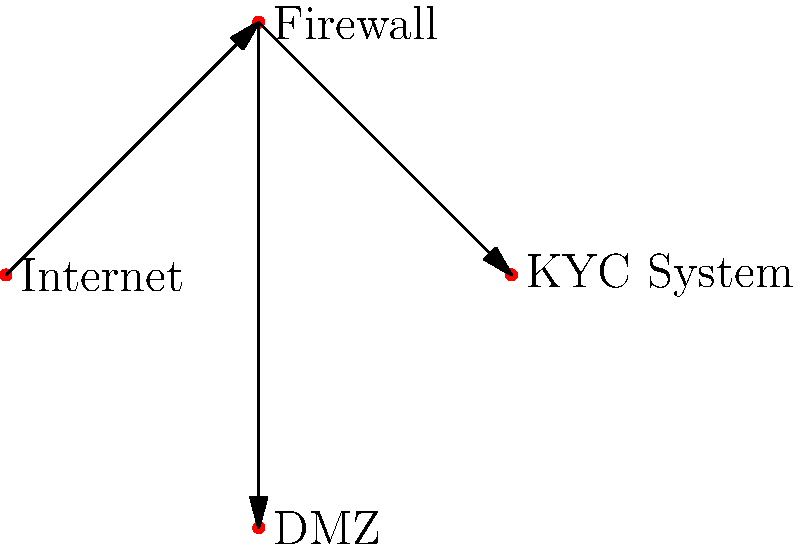In the network diagram shown, which firewall configuration would best protect sensitive customer data in the KYC system while allowing necessary access for agile development and updates? To determine the best firewall configuration for protecting sensitive customer data in a KYC system while allowing necessary access for agile development, we need to consider several factors:

1. Segmentation: The diagram shows a DMZ (Demilitarized Zone) separate from the KYC system, which is a good practice for isolating sensitive systems.

2. Access Control:
   a) Inbound traffic from the Internet should be strictly limited.
   b) Only necessary ports and protocols should be allowed to the KYC system.
   c) Access for development and updates should be controlled and monitored.

3. Rule Configuration:
   a) Default deny all inbound and outbound traffic.
   b) Allow only specific, necessary traffic to the KYC system.
   c) Implement stateful inspection for all allowed connections.

4. Application-layer filtering: Use application-layer firewalls to inspect and filter traffic based on the content and context of the data.

5. Logging and Monitoring: Enable comprehensive logging and real-time monitoring of all firewall activities.

6. VPN for remote access: Implement a secure VPN for developers to access the system remotely.

7. Regular updates: Keep the firewall software and rules up-to-date with the latest security patches and best practices.

The best configuration would be a next-generation firewall (NGFW) that combines traditional firewall capabilities with advanced features such as intrusion prevention, application awareness, and integrated threat intelligence. This would allow for:

- Strict control over inbound and outbound traffic
- Deep packet inspection for all traffic to and from the KYC system
- Application-level filtering to ensure only authorized applications can access sensitive data
- Integration with identity and access management systems for granular user control
- Secure VPN access for developers working on agile updates
- Comprehensive logging and monitoring capabilities for compliance and security audits

This configuration provides a balance between protecting sensitive customer data and allowing necessary access for agile development and updates.
Answer: Next-generation firewall (NGFW) with application-aware policies, deep packet inspection, and secure VPN access 